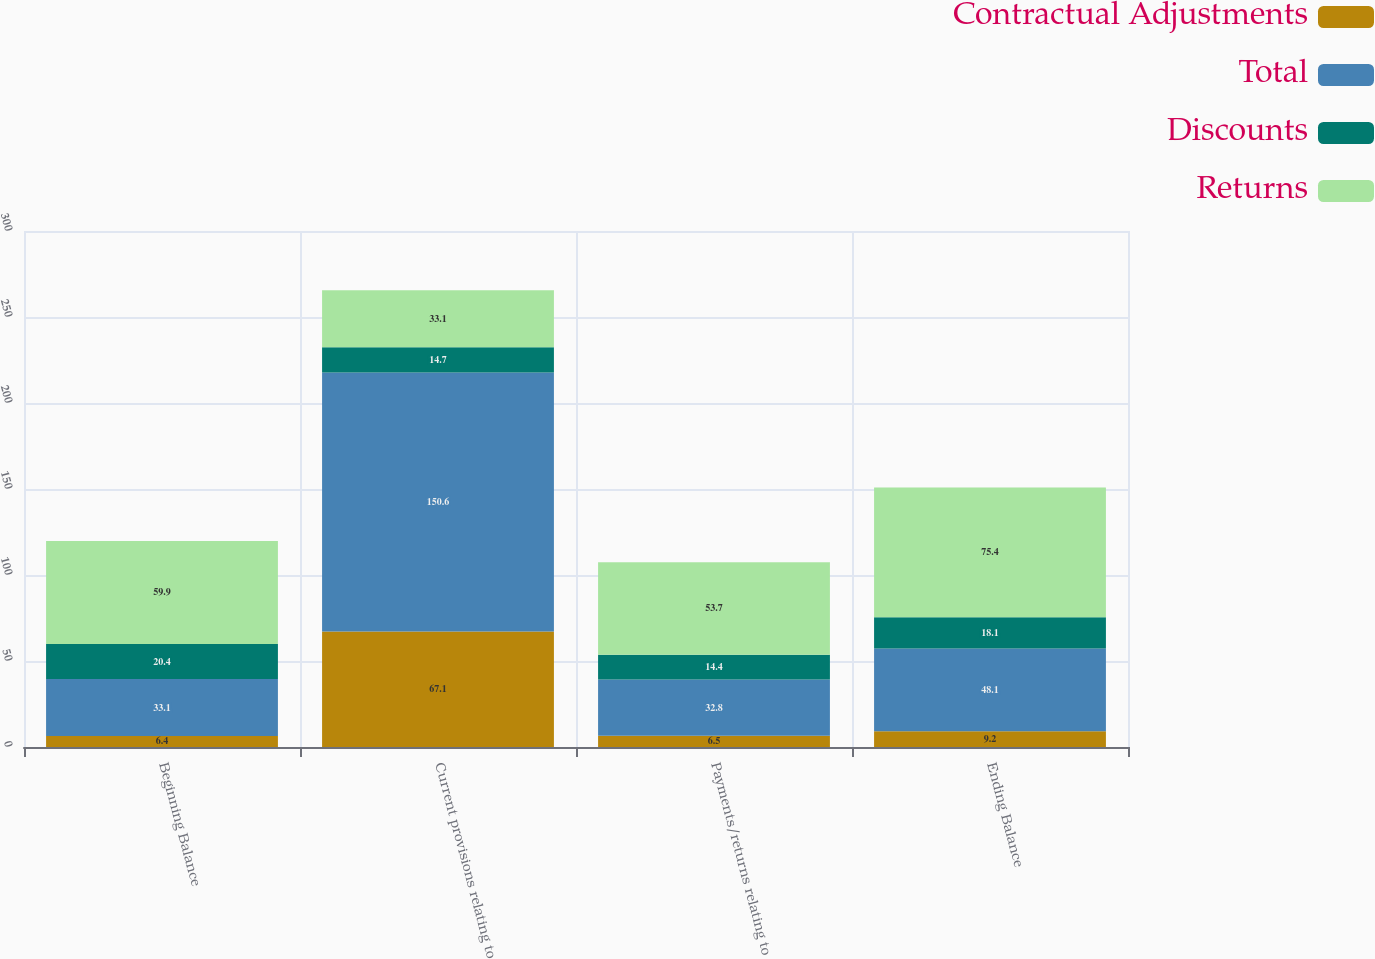Convert chart to OTSL. <chart><loc_0><loc_0><loc_500><loc_500><stacked_bar_chart><ecel><fcel>Beginning Balance<fcel>Current provisions relating to<fcel>Payments/returns relating to<fcel>Ending Balance<nl><fcel>Contractual Adjustments<fcel>6.4<fcel>67.1<fcel>6.5<fcel>9.2<nl><fcel>Total<fcel>33.1<fcel>150.6<fcel>32.8<fcel>48.1<nl><fcel>Discounts<fcel>20.4<fcel>14.7<fcel>14.4<fcel>18.1<nl><fcel>Returns<fcel>59.9<fcel>33.1<fcel>53.7<fcel>75.4<nl></chart> 